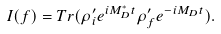<formula> <loc_0><loc_0><loc_500><loc_500>I ( f ) = T r ( \rho _ { i } ^ { \prime } e ^ { i M _ { D } ^ { * } t } \rho _ { f } ^ { \prime } e ^ { - i M _ { D } t } ) .</formula> 